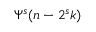<formula> <loc_0><loc_0><loc_500><loc_500>{ \Psi } ^ { s } ( n - 2 ^ { s } k )</formula> 